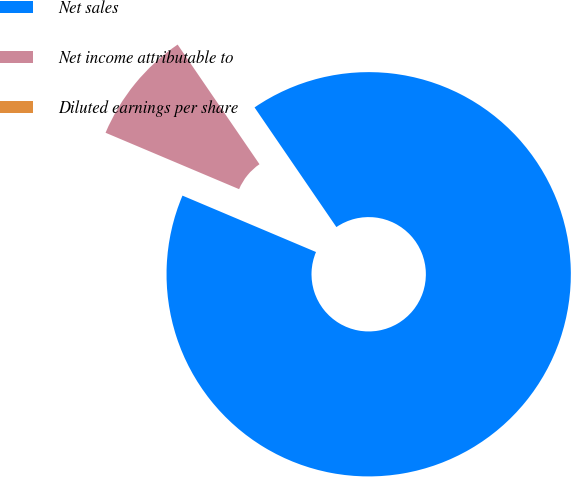Convert chart to OTSL. <chart><loc_0><loc_0><loc_500><loc_500><pie_chart><fcel>Net sales<fcel>Net income attributable to<fcel>Diluted earnings per share<nl><fcel>90.91%<fcel>9.09%<fcel>0.0%<nl></chart> 